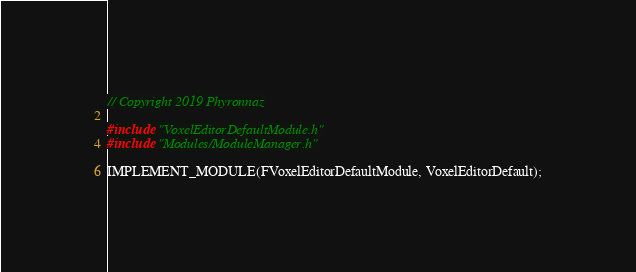Convert code to text. <code><loc_0><loc_0><loc_500><loc_500><_C++_>// Copyright 2019 Phyronnaz

#include "VoxelEditorDefaultModule.h"
#include "Modules/ModuleManager.h"

IMPLEMENT_MODULE(FVoxelEditorDefaultModule, VoxelEditorDefault);

</code> 